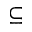Convert formula to latex. <formula><loc_0><loc_0><loc_500><loc_500>\subseteq</formula> 